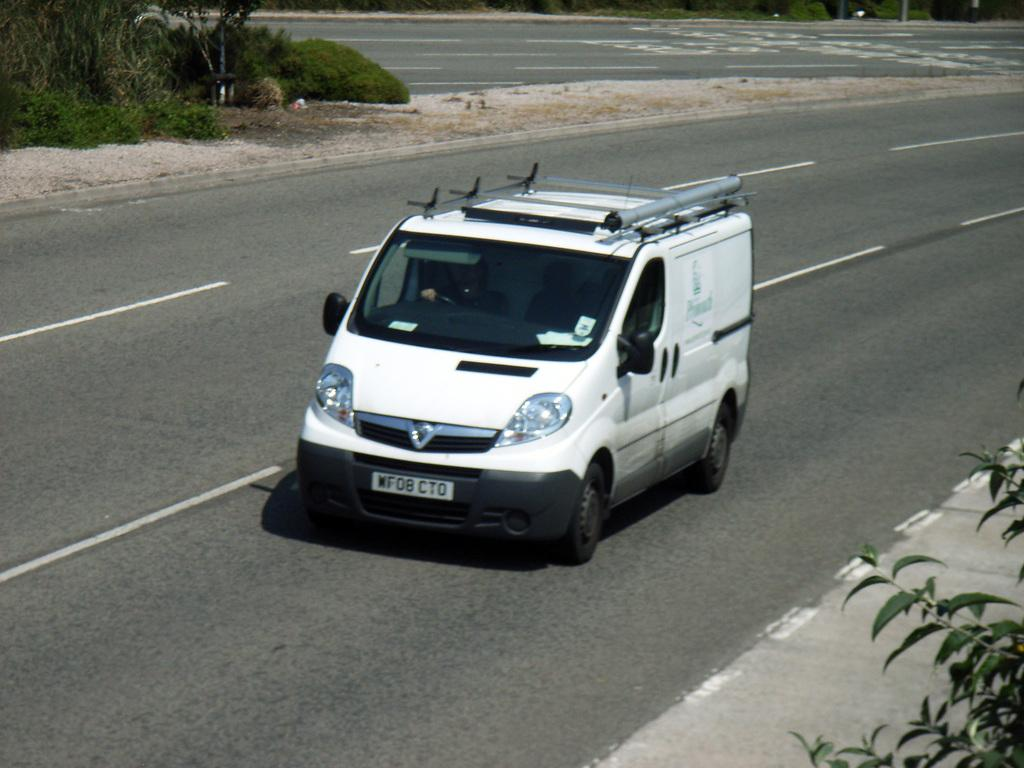What is the person in the image doing? There is a person driving a vehicle in the image. Can you describe the road in the image? There is a two-way road in the image. What else can be seen in the image besides the vehicle and road? There are many plants in the image. How many folds are visible in the stocking of the person driving the vehicle in the image? There is no stocking visible in the image, and therefore no folds can be observed. What type of pan is being used to cook on the side of the road in the image? There is no pan present in the image; it features a person driving a vehicle on a two-way road with many plants. 